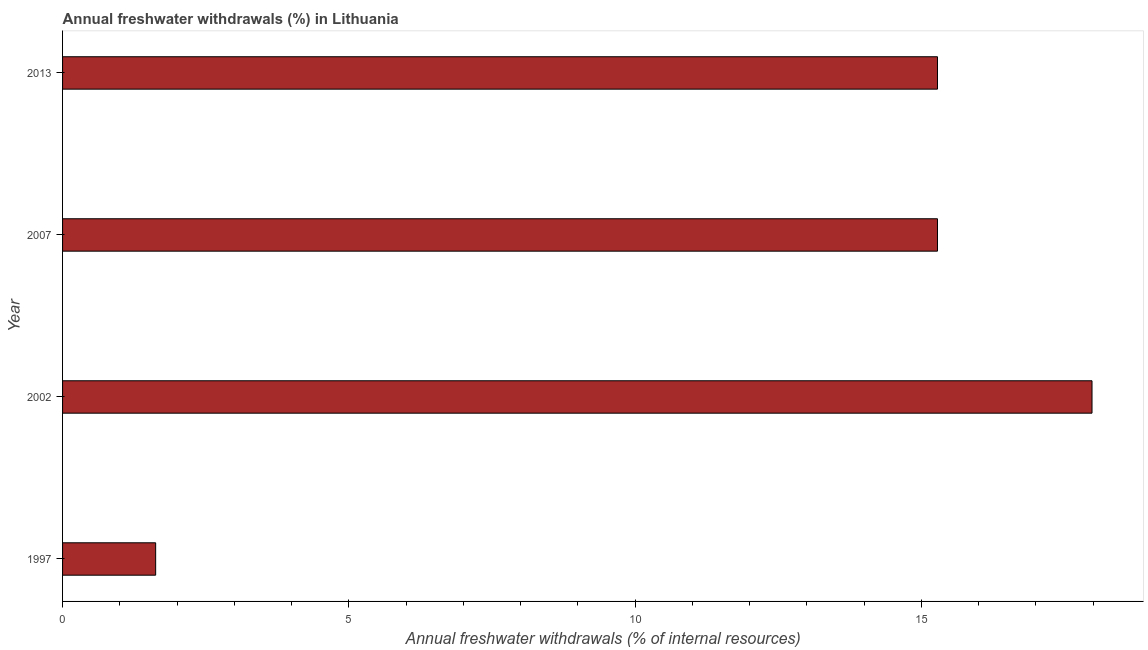What is the title of the graph?
Your answer should be very brief. Annual freshwater withdrawals (%) in Lithuania. What is the label or title of the X-axis?
Offer a very short reply. Annual freshwater withdrawals (% of internal resources). What is the label or title of the Y-axis?
Make the answer very short. Year. What is the annual freshwater withdrawals in 2002?
Keep it short and to the point. 17.98. Across all years, what is the maximum annual freshwater withdrawals?
Provide a short and direct response. 17.98. Across all years, what is the minimum annual freshwater withdrawals?
Your answer should be very brief. 1.63. What is the sum of the annual freshwater withdrawals?
Give a very brief answer. 50.17. What is the difference between the annual freshwater withdrawals in 1997 and 2013?
Give a very brief answer. -13.66. What is the average annual freshwater withdrawals per year?
Keep it short and to the point. 12.54. What is the median annual freshwater withdrawals?
Your answer should be very brief. 15.28. What is the ratio of the annual freshwater withdrawals in 2002 to that in 2013?
Make the answer very short. 1.18. Is the difference between the annual freshwater withdrawals in 2002 and 2007 greater than the difference between any two years?
Offer a terse response. No. What is the difference between the highest and the second highest annual freshwater withdrawals?
Ensure brevity in your answer.  2.7. Is the sum of the annual freshwater withdrawals in 1997 and 2007 greater than the maximum annual freshwater withdrawals across all years?
Your answer should be very brief. No. What is the difference between the highest and the lowest annual freshwater withdrawals?
Ensure brevity in your answer.  16.36. In how many years, is the annual freshwater withdrawals greater than the average annual freshwater withdrawals taken over all years?
Your answer should be compact. 3. How many bars are there?
Make the answer very short. 4. How many years are there in the graph?
Your response must be concise. 4. What is the difference between two consecutive major ticks on the X-axis?
Keep it short and to the point. 5. What is the Annual freshwater withdrawals (% of internal resources) in 1997?
Offer a very short reply. 1.63. What is the Annual freshwater withdrawals (% of internal resources) of 2002?
Provide a succinct answer. 17.98. What is the Annual freshwater withdrawals (% of internal resources) in 2007?
Keep it short and to the point. 15.28. What is the Annual freshwater withdrawals (% of internal resources) of 2013?
Provide a succinct answer. 15.28. What is the difference between the Annual freshwater withdrawals (% of internal resources) in 1997 and 2002?
Give a very brief answer. -16.36. What is the difference between the Annual freshwater withdrawals (% of internal resources) in 1997 and 2007?
Ensure brevity in your answer.  -13.66. What is the difference between the Annual freshwater withdrawals (% of internal resources) in 1997 and 2013?
Your response must be concise. -13.66. What is the difference between the Annual freshwater withdrawals (% of internal resources) in 2002 and 2007?
Give a very brief answer. 2.7. What is the difference between the Annual freshwater withdrawals (% of internal resources) in 2002 and 2013?
Give a very brief answer. 2.7. What is the difference between the Annual freshwater withdrawals (% of internal resources) in 2007 and 2013?
Provide a succinct answer. 0. What is the ratio of the Annual freshwater withdrawals (% of internal resources) in 1997 to that in 2002?
Offer a very short reply. 0.09. What is the ratio of the Annual freshwater withdrawals (% of internal resources) in 1997 to that in 2007?
Offer a terse response. 0.11. What is the ratio of the Annual freshwater withdrawals (% of internal resources) in 1997 to that in 2013?
Your response must be concise. 0.11. What is the ratio of the Annual freshwater withdrawals (% of internal resources) in 2002 to that in 2007?
Give a very brief answer. 1.18. What is the ratio of the Annual freshwater withdrawals (% of internal resources) in 2002 to that in 2013?
Provide a succinct answer. 1.18. What is the ratio of the Annual freshwater withdrawals (% of internal resources) in 2007 to that in 2013?
Offer a very short reply. 1. 